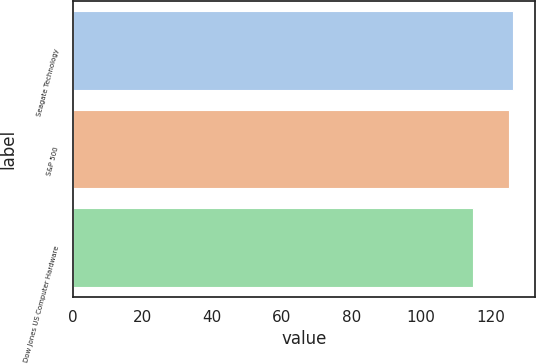Convert chart. <chart><loc_0><loc_0><loc_500><loc_500><bar_chart><fcel>Seagate Technology<fcel>S&P 500<fcel>Dow Jones US Computer Hardware<nl><fcel>126.37<fcel>125.29<fcel>115.05<nl></chart> 